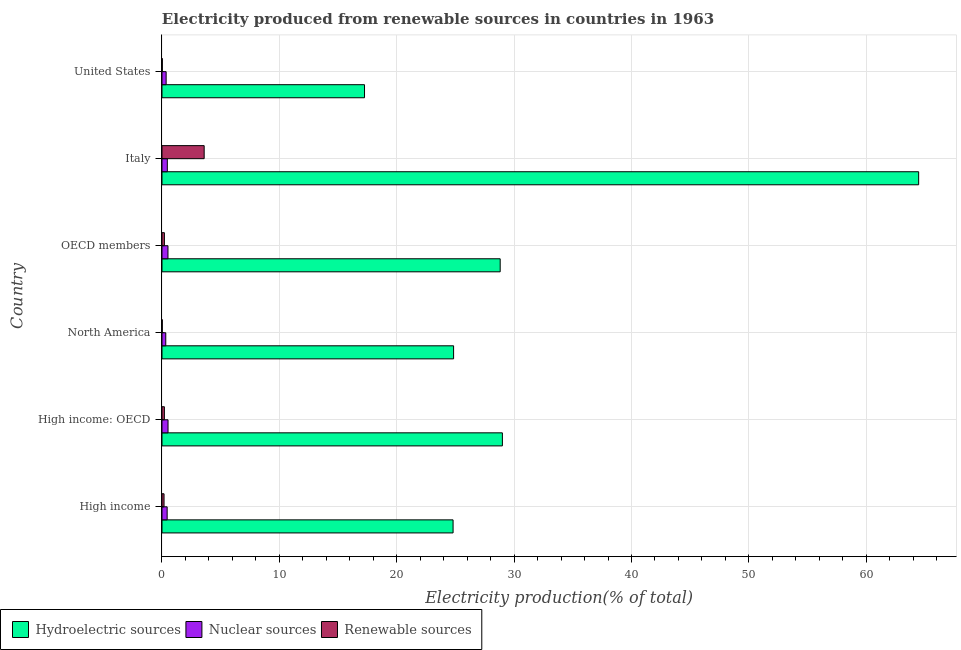How many different coloured bars are there?
Make the answer very short. 3. How many groups of bars are there?
Your answer should be compact. 6. Are the number of bars per tick equal to the number of legend labels?
Your answer should be compact. Yes. How many bars are there on the 1st tick from the bottom?
Your answer should be compact. 3. What is the percentage of electricity produced by nuclear sources in Italy?
Ensure brevity in your answer.  0.45. Across all countries, what is the maximum percentage of electricity produced by nuclear sources?
Keep it short and to the point. 0.52. Across all countries, what is the minimum percentage of electricity produced by renewable sources?
Offer a terse response. 0.03. In which country was the percentage of electricity produced by renewable sources maximum?
Offer a terse response. Italy. What is the total percentage of electricity produced by hydroelectric sources in the graph?
Keep it short and to the point. 189.19. What is the difference between the percentage of electricity produced by nuclear sources in High income and that in OECD members?
Your answer should be compact. -0.07. What is the difference between the percentage of electricity produced by hydroelectric sources in OECD members and the percentage of electricity produced by nuclear sources in North America?
Ensure brevity in your answer.  28.49. What is the average percentage of electricity produced by hydroelectric sources per country?
Provide a succinct answer. 31.53. What is the difference between the percentage of electricity produced by renewable sources and percentage of electricity produced by hydroelectric sources in High income: OECD?
Your answer should be very brief. -28.8. In how many countries, is the percentage of electricity produced by hydroelectric sources greater than 16 %?
Provide a short and direct response. 6. What is the ratio of the percentage of electricity produced by nuclear sources in High income to that in United States?
Offer a terse response. 1.25. Is the percentage of electricity produced by hydroelectric sources in High income: OECD less than that in Italy?
Provide a succinct answer. Yes. Is the difference between the percentage of electricity produced by hydroelectric sources in Italy and United States greater than the difference between the percentage of electricity produced by nuclear sources in Italy and United States?
Offer a terse response. Yes. What is the difference between the highest and the second highest percentage of electricity produced by hydroelectric sources?
Your answer should be very brief. 35.47. What is the difference between the highest and the lowest percentage of electricity produced by nuclear sources?
Your answer should be compact. 0.19. In how many countries, is the percentage of electricity produced by hydroelectric sources greater than the average percentage of electricity produced by hydroelectric sources taken over all countries?
Ensure brevity in your answer.  1. Is the sum of the percentage of electricity produced by renewable sources in High income: OECD and North America greater than the maximum percentage of electricity produced by hydroelectric sources across all countries?
Your answer should be compact. No. What does the 3rd bar from the top in United States represents?
Provide a short and direct response. Hydroelectric sources. What does the 1st bar from the bottom in OECD members represents?
Your answer should be very brief. Hydroelectric sources. Is it the case that in every country, the sum of the percentage of electricity produced by hydroelectric sources and percentage of electricity produced by nuclear sources is greater than the percentage of electricity produced by renewable sources?
Your answer should be very brief. Yes. What is the difference between two consecutive major ticks on the X-axis?
Keep it short and to the point. 10. Does the graph contain any zero values?
Provide a succinct answer. No. How many legend labels are there?
Provide a succinct answer. 3. How are the legend labels stacked?
Your response must be concise. Horizontal. What is the title of the graph?
Provide a short and direct response. Electricity produced from renewable sources in countries in 1963. What is the Electricity production(% of total) in Hydroelectric sources in High income?
Provide a succinct answer. 24.8. What is the Electricity production(% of total) of Nuclear sources in High income?
Give a very brief answer. 0.44. What is the Electricity production(% of total) in Renewable sources in High income?
Your response must be concise. 0.18. What is the Electricity production(% of total) in Hydroelectric sources in High income: OECD?
Keep it short and to the point. 29. What is the Electricity production(% of total) of Nuclear sources in High income: OECD?
Make the answer very short. 0.52. What is the Electricity production(% of total) in Renewable sources in High income: OECD?
Ensure brevity in your answer.  0.21. What is the Electricity production(% of total) of Hydroelectric sources in North America?
Ensure brevity in your answer.  24.84. What is the Electricity production(% of total) in Nuclear sources in North America?
Your answer should be very brief. 0.32. What is the Electricity production(% of total) of Renewable sources in North America?
Provide a short and direct response. 0.03. What is the Electricity production(% of total) in Hydroelectric sources in OECD members?
Offer a very short reply. 28.81. What is the Electricity production(% of total) in Nuclear sources in OECD members?
Give a very brief answer. 0.51. What is the Electricity production(% of total) of Renewable sources in OECD members?
Offer a terse response. 0.21. What is the Electricity production(% of total) in Hydroelectric sources in Italy?
Your response must be concise. 64.47. What is the Electricity production(% of total) in Nuclear sources in Italy?
Provide a short and direct response. 0.45. What is the Electricity production(% of total) of Renewable sources in Italy?
Your response must be concise. 3.59. What is the Electricity production(% of total) of Hydroelectric sources in United States?
Your response must be concise. 17.26. What is the Electricity production(% of total) of Nuclear sources in United States?
Provide a short and direct response. 0.35. What is the Electricity production(% of total) of Renewable sources in United States?
Keep it short and to the point. 0.03. Across all countries, what is the maximum Electricity production(% of total) in Hydroelectric sources?
Offer a very short reply. 64.47. Across all countries, what is the maximum Electricity production(% of total) in Nuclear sources?
Make the answer very short. 0.52. Across all countries, what is the maximum Electricity production(% of total) of Renewable sources?
Keep it short and to the point. 3.59. Across all countries, what is the minimum Electricity production(% of total) in Hydroelectric sources?
Make the answer very short. 17.26. Across all countries, what is the minimum Electricity production(% of total) in Nuclear sources?
Make the answer very short. 0.32. Across all countries, what is the minimum Electricity production(% of total) in Renewable sources?
Offer a very short reply. 0.03. What is the total Electricity production(% of total) in Hydroelectric sources in the graph?
Keep it short and to the point. 189.19. What is the total Electricity production(% of total) of Nuclear sources in the graph?
Ensure brevity in your answer.  2.6. What is the total Electricity production(% of total) in Renewable sources in the graph?
Ensure brevity in your answer.  4.24. What is the difference between the Electricity production(% of total) in Hydroelectric sources in High income and that in High income: OECD?
Give a very brief answer. -4.2. What is the difference between the Electricity production(% of total) of Nuclear sources in High income and that in High income: OECD?
Give a very brief answer. -0.07. What is the difference between the Electricity production(% of total) of Renewable sources in High income and that in High income: OECD?
Your answer should be compact. -0.03. What is the difference between the Electricity production(% of total) of Hydroelectric sources in High income and that in North America?
Your answer should be compact. -0.04. What is the difference between the Electricity production(% of total) in Nuclear sources in High income and that in North America?
Your answer should be compact. 0.12. What is the difference between the Electricity production(% of total) in Renewable sources in High income and that in North America?
Offer a very short reply. 0.15. What is the difference between the Electricity production(% of total) in Hydroelectric sources in High income and that in OECD members?
Make the answer very short. -4.01. What is the difference between the Electricity production(% of total) in Nuclear sources in High income and that in OECD members?
Your answer should be very brief. -0.07. What is the difference between the Electricity production(% of total) of Renewable sources in High income and that in OECD members?
Offer a terse response. -0.03. What is the difference between the Electricity production(% of total) of Hydroelectric sources in High income and that in Italy?
Your answer should be very brief. -39.67. What is the difference between the Electricity production(% of total) of Nuclear sources in High income and that in Italy?
Offer a very short reply. -0.01. What is the difference between the Electricity production(% of total) in Renewable sources in High income and that in Italy?
Your answer should be compact. -3.42. What is the difference between the Electricity production(% of total) of Hydroelectric sources in High income and that in United States?
Keep it short and to the point. 7.55. What is the difference between the Electricity production(% of total) in Nuclear sources in High income and that in United States?
Your answer should be compact. 0.09. What is the difference between the Electricity production(% of total) in Renewable sources in High income and that in United States?
Your answer should be compact. 0.15. What is the difference between the Electricity production(% of total) in Hydroelectric sources in High income: OECD and that in North America?
Offer a terse response. 4.16. What is the difference between the Electricity production(% of total) in Nuclear sources in High income: OECD and that in North America?
Your answer should be compact. 0.19. What is the difference between the Electricity production(% of total) in Renewable sources in High income: OECD and that in North America?
Your answer should be very brief. 0.18. What is the difference between the Electricity production(% of total) of Hydroelectric sources in High income: OECD and that in OECD members?
Make the answer very short. 0.19. What is the difference between the Electricity production(% of total) of Nuclear sources in High income: OECD and that in OECD members?
Make the answer very short. 0.01. What is the difference between the Electricity production(% of total) of Renewable sources in High income: OECD and that in OECD members?
Offer a very short reply. -0. What is the difference between the Electricity production(% of total) in Hydroelectric sources in High income: OECD and that in Italy?
Your answer should be very brief. -35.47. What is the difference between the Electricity production(% of total) of Nuclear sources in High income: OECD and that in Italy?
Give a very brief answer. 0.06. What is the difference between the Electricity production(% of total) in Renewable sources in High income: OECD and that in Italy?
Make the answer very short. -3.39. What is the difference between the Electricity production(% of total) of Hydroelectric sources in High income: OECD and that in United States?
Give a very brief answer. 11.75. What is the difference between the Electricity production(% of total) of Nuclear sources in High income: OECD and that in United States?
Provide a succinct answer. 0.16. What is the difference between the Electricity production(% of total) of Renewable sources in High income: OECD and that in United States?
Make the answer very short. 0.18. What is the difference between the Electricity production(% of total) in Hydroelectric sources in North America and that in OECD members?
Keep it short and to the point. -3.97. What is the difference between the Electricity production(% of total) of Nuclear sources in North America and that in OECD members?
Provide a short and direct response. -0.19. What is the difference between the Electricity production(% of total) of Renewable sources in North America and that in OECD members?
Provide a succinct answer. -0.18. What is the difference between the Electricity production(% of total) of Hydroelectric sources in North America and that in Italy?
Your response must be concise. -39.62. What is the difference between the Electricity production(% of total) in Nuclear sources in North America and that in Italy?
Offer a terse response. -0.13. What is the difference between the Electricity production(% of total) of Renewable sources in North America and that in Italy?
Your answer should be compact. -3.57. What is the difference between the Electricity production(% of total) in Hydroelectric sources in North America and that in United States?
Your answer should be compact. 7.59. What is the difference between the Electricity production(% of total) in Nuclear sources in North America and that in United States?
Your answer should be compact. -0.03. What is the difference between the Electricity production(% of total) of Renewable sources in North America and that in United States?
Give a very brief answer. -0. What is the difference between the Electricity production(% of total) of Hydroelectric sources in OECD members and that in Italy?
Make the answer very short. -35.65. What is the difference between the Electricity production(% of total) in Nuclear sources in OECD members and that in Italy?
Give a very brief answer. 0.06. What is the difference between the Electricity production(% of total) in Renewable sources in OECD members and that in Italy?
Your answer should be compact. -3.39. What is the difference between the Electricity production(% of total) in Hydroelectric sources in OECD members and that in United States?
Ensure brevity in your answer.  11.56. What is the difference between the Electricity production(% of total) of Nuclear sources in OECD members and that in United States?
Provide a succinct answer. 0.16. What is the difference between the Electricity production(% of total) of Renewable sources in OECD members and that in United States?
Provide a short and direct response. 0.18. What is the difference between the Electricity production(% of total) in Hydroelectric sources in Italy and that in United States?
Provide a short and direct response. 47.21. What is the difference between the Electricity production(% of total) in Nuclear sources in Italy and that in United States?
Make the answer very short. 0.1. What is the difference between the Electricity production(% of total) in Renewable sources in Italy and that in United States?
Provide a short and direct response. 3.56. What is the difference between the Electricity production(% of total) of Hydroelectric sources in High income and the Electricity production(% of total) of Nuclear sources in High income: OECD?
Make the answer very short. 24.29. What is the difference between the Electricity production(% of total) in Hydroelectric sources in High income and the Electricity production(% of total) in Renewable sources in High income: OECD?
Your answer should be compact. 24.6. What is the difference between the Electricity production(% of total) in Nuclear sources in High income and the Electricity production(% of total) in Renewable sources in High income: OECD?
Provide a short and direct response. 0.24. What is the difference between the Electricity production(% of total) in Hydroelectric sources in High income and the Electricity production(% of total) in Nuclear sources in North America?
Ensure brevity in your answer.  24.48. What is the difference between the Electricity production(% of total) in Hydroelectric sources in High income and the Electricity production(% of total) in Renewable sources in North America?
Give a very brief answer. 24.77. What is the difference between the Electricity production(% of total) of Nuclear sources in High income and the Electricity production(% of total) of Renewable sources in North America?
Offer a terse response. 0.41. What is the difference between the Electricity production(% of total) of Hydroelectric sources in High income and the Electricity production(% of total) of Nuclear sources in OECD members?
Offer a terse response. 24.29. What is the difference between the Electricity production(% of total) of Hydroelectric sources in High income and the Electricity production(% of total) of Renewable sources in OECD members?
Provide a short and direct response. 24.59. What is the difference between the Electricity production(% of total) in Nuclear sources in High income and the Electricity production(% of total) in Renewable sources in OECD members?
Offer a very short reply. 0.23. What is the difference between the Electricity production(% of total) in Hydroelectric sources in High income and the Electricity production(% of total) in Nuclear sources in Italy?
Give a very brief answer. 24.35. What is the difference between the Electricity production(% of total) in Hydroelectric sources in High income and the Electricity production(% of total) in Renewable sources in Italy?
Offer a very short reply. 21.21. What is the difference between the Electricity production(% of total) of Nuclear sources in High income and the Electricity production(% of total) of Renewable sources in Italy?
Your answer should be very brief. -3.15. What is the difference between the Electricity production(% of total) in Hydroelectric sources in High income and the Electricity production(% of total) in Nuclear sources in United States?
Your response must be concise. 24.45. What is the difference between the Electricity production(% of total) of Hydroelectric sources in High income and the Electricity production(% of total) of Renewable sources in United States?
Your response must be concise. 24.77. What is the difference between the Electricity production(% of total) of Nuclear sources in High income and the Electricity production(% of total) of Renewable sources in United States?
Ensure brevity in your answer.  0.41. What is the difference between the Electricity production(% of total) of Hydroelectric sources in High income: OECD and the Electricity production(% of total) of Nuclear sources in North America?
Provide a succinct answer. 28.68. What is the difference between the Electricity production(% of total) in Hydroelectric sources in High income: OECD and the Electricity production(% of total) in Renewable sources in North America?
Provide a short and direct response. 28.98. What is the difference between the Electricity production(% of total) of Nuclear sources in High income: OECD and the Electricity production(% of total) of Renewable sources in North America?
Keep it short and to the point. 0.49. What is the difference between the Electricity production(% of total) in Hydroelectric sources in High income: OECD and the Electricity production(% of total) in Nuclear sources in OECD members?
Your answer should be very brief. 28.49. What is the difference between the Electricity production(% of total) of Hydroelectric sources in High income: OECD and the Electricity production(% of total) of Renewable sources in OECD members?
Your answer should be compact. 28.8. What is the difference between the Electricity production(% of total) in Nuclear sources in High income: OECD and the Electricity production(% of total) in Renewable sources in OECD members?
Ensure brevity in your answer.  0.31. What is the difference between the Electricity production(% of total) in Hydroelectric sources in High income: OECD and the Electricity production(% of total) in Nuclear sources in Italy?
Your answer should be very brief. 28.55. What is the difference between the Electricity production(% of total) of Hydroelectric sources in High income: OECD and the Electricity production(% of total) of Renewable sources in Italy?
Your answer should be compact. 25.41. What is the difference between the Electricity production(% of total) of Nuclear sources in High income: OECD and the Electricity production(% of total) of Renewable sources in Italy?
Make the answer very short. -3.08. What is the difference between the Electricity production(% of total) of Hydroelectric sources in High income: OECD and the Electricity production(% of total) of Nuclear sources in United States?
Keep it short and to the point. 28.65. What is the difference between the Electricity production(% of total) of Hydroelectric sources in High income: OECD and the Electricity production(% of total) of Renewable sources in United States?
Your answer should be very brief. 28.97. What is the difference between the Electricity production(% of total) of Nuclear sources in High income: OECD and the Electricity production(% of total) of Renewable sources in United States?
Provide a short and direct response. 0.49. What is the difference between the Electricity production(% of total) of Hydroelectric sources in North America and the Electricity production(% of total) of Nuclear sources in OECD members?
Offer a terse response. 24.33. What is the difference between the Electricity production(% of total) in Hydroelectric sources in North America and the Electricity production(% of total) in Renewable sources in OECD members?
Your answer should be very brief. 24.64. What is the difference between the Electricity production(% of total) in Nuclear sources in North America and the Electricity production(% of total) in Renewable sources in OECD members?
Make the answer very short. 0.12. What is the difference between the Electricity production(% of total) of Hydroelectric sources in North America and the Electricity production(% of total) of Nuclear sources in Italy?
Keep it short and to the point. 24.39. What is the difference between the Electricity production(% of total) in Hydroelectric sources in North America and the Electricity production(% of total) in Renewable sources in Italy?
Offer a terse response. 21.25. What is the difference between the Electricity production(% of total) of Nuclear sources in North America and the Electricity production(% of total) of Renewable sources in Italy?
Offer a terse response. -3.27. What is the difference between the Electricity production(% of total) of Hydroelectric sources in North America and the Electricity production(% of total) of Nuclear sources in United States?
Offer a terse response. 24.49. What is the difference between the Electricity production(% of total) of Hydroelectric sources in North America and the Electricity production(% of total) of Renewable sources in United States?
Your response must be concise. 24.82. What is the difference between the Electricity production(% of total) in Nuclear sources in North America and the Electricity production(% of total) in Renewable sources in United States?
Ensure brevity in your answer.  0.29. What is the difference between the Electricity production(% of total) of Hydroelectric sources in OECD members and the Electricity production(% of total) of Nuclear sources in Italy?
Ensure brevity in your answer.  28.36. What is the difference between the Electricity production(% of total) of Hydroelectric sources in OECD members and the Electricity production(% of total) of Renewable sources in Italy?
Provide a short and direct response. 25.22. What is the difference between the Electricity production(% of total) of Nuclear sources in OECD members and the Electricity production(% of total) of Renewable sources in Italy?
Make the answer very short. -3.08. What is the difference between the Electricity production(% of total) in Hydroelectric sources in OECD members and the Electricity production(% of total) in Nuclear sources in United States?
Make the answer very short. 28.46. What is the difference between the Electricity production(% of total) in Hydroelectric sources in OECD members and the Electricity production(% of total) in Renewable sources in United States?
Your answer should be compact. 28.79. What is the difference between the Electricity production(% of total) of Nuclear sources in OECD members and the Electricity production(% of total) of Renewable sources in United States?
Your answer should be very brief. 0.48. What is the difference between the Electricity production(% of total) in Hydroelectric sources in Italy and the Electricity production(% of total) in Nuclear sources in United States?
Provide a succinct answer. 64.11. What is the difference between the Electricity production(% of total) in Hydroelectric sources in Italy and the Electricity production(% of total) in Renewable sources in United States?
Keep it short and to the point. 64.44. What is the difference between the Electricity production(% of total) of Nuclear sources in Italy and the Electricity production(% of total) of Renewable sources in United States?
Your response must be concise. 0.43. What is the average Electricity production(% of total) of Hydroelectric sources per country?
Keep it short and to the point. 31.53. What is the average Electricity production(% of total) in Nuclear sources per country?
Ensure brevity in your answer.  0.43. What is the average Electricity production(% of total) in Renewable sources per country?
Give a very brief answer. 0.71. What is the difference between the Electricity production(% of total) of Hydroelectric sources and Electricity production(% of total) of Nuclear sources in High income?
Your answer should be very brief. 24.36. What is the difference between the Electricity production(% of total) of Hydroelectric sources and Electricity production(% of total) of Renewable sources in High income?
Provide a short and direct response. 24.63. What is the difference between the Electricity production(% of total) of Nuclear sources and Electricity production(% of total) of Renewable sources in High income?
Your response must be concise. 0.27. What is the difference between the Electricity production(% of total) of Hydroelectric sources and Electricity production(% of total) of Nuclear sources in High income: OECD?
Provide a short and direct response. 28.49. What is the difference between the Electricity production(% of total) in Hydroelectric sources and Electricity production(% of total) in Renewable sources in High income: OECD?
Your answer should be very brief. 28.8. What is the difference between the Electricity production(% of total) in Nuclear sources and Electricity production(% of total) in Renewable sources in High income: OECD?
Offer a terse response. 0.31. What is the difference between the Electricity production(% of total) in Hydroelectric sources and Electricity production(% of total) in Nuclear sources in North America?
Your response must be concise. 24.52. What is the difference between the Electricity production(% of total) of Hydroelectric sources and Electricity production(% of total) of Renewable sources in North America?
Your answer should be very brief. 24.82. What is the difference between the Electricity production(% of total) of Nuclear sources and Electricity production(% of total) of Renewable sources in North America?
Make the answer very short. 0.3. What is the difference between the Electricity production(% of total) of Hydroelectric sources and Electricity production(% of total) of Nuclear sources in OECD members?
Make the answer very short. 28.3. What is the difference between the Electricity production(% of total) in Hydroelectric sources and Electricity production(% of total) in Renewable sources in OECD members?
Make the answer very short. 28.61. What is the difference between the Electricity production(% of total) of Nuclear sources and Electricity production(% of total) of Renewable sources in OECD members?
Provide a succinct answer. 0.3. What is the difference between the Electricity production(% of total) in Hydroelectric sources and Electricity production(% of total) in Nuclear sources in Italy?
Ensure brevity in your answer.  64.01. What is the difference between the Electricity production(% of total) in Hydroelectric sources and Electricity production(% of total) in Renewable sources in Italy?
Make the answer very short. 60.87. What is the difference between the Electricity production(% of total) of Nuclear sources and Electricity production(% of total) of Renewable sources in Italy?
Give a very brief answer. -3.14. What is the difference between the Electricity production(% of total) of Hydroelectric sources and Electricity production(% of total) of Nuclear sources in United States?
Keep it short and to the point. 16.9. What is the difference between the Electricity production(% of total) in Hydroelectric sources and Electricity production(% of total) in Renewable sources in United States?
Make the answer very short. 17.23. What is the difference between the Electricity production(% of total) of Nuclear sources and Electricity production(% of total) of Renewable sources in United States?
Your answer should be very brief. 0.32. What is the ratio of the Electricity production(% of total) of Hydroelectric sources in High income to that in High income: OECD?
Offer a terse response. 0.86. What is the ratio of the Electricity production(% of total) of Nuclear sources in High income to that in High income: OECD?
Give a very brief answer. 0.86. What is the ratio of the Electricity production(% of total) in Renewable sources in High income to that in High income: OECD?
Your answer should be very brief. 0.86. What is the ratio of the Electricity production(% of total) of Hydroelectric sources in High income to that in North America?
Your response must be concise. 1. What is the ratio of the Electricity production(% of total) of Nuclear sources in High income to that in North America?
Keep it short and to the point. 1.37. What is the ratio of the Electricity production(% of total) in Renewable sources in High income to that in North America?
Provide a succinct answer. 6.73. What is the ratio of the Electricity production(% of total) of Hydroelectric sources in High income to that in OECD members?
Your answer should be compact. 0.86. What is the ratio of the Electricity production(% of total) of Nuclear sources in High income to that in OECD members?
Your response must be concise. 0.86. What is the ratio of the Electricity production(% of total) of Renewable sources in High income to that in OECD members?
Your answer should be very brief. 0.85. What is the ratio of the Electricity production(% of total) in Hydroelectric sources in High income to that in Italy?
Your response must be concise. 0.38. What is the ratio of the Electricity production(% of total) of Nuclear sources in High income to that in Italy?
Offer a very short reply. 0.97. What is the ratio of the Electricity production(% of total) in Renewable sources in High income to that in Italy?
Your answer should be very brief. 0.05. What is the ratio of the Electricity production(% of total) of Hydroelectric sources in High income to that in United States?
Ensure brevity in your answer.  1.44. What is the ratio of the Electricity production(% of total) of Nuclear sources in High income to that in United States?
Provide a succinct answer. 1.25. What is the ratio of the Electricity production(% of total) in Renewable sources in High income to that in United States?
Offer a terse response. 5.97. What is the ratio of the Electricity production(% of total) of Hydroelectric sources in High income: OECD to that in North America?
Provide a short and direct response. 1.17. What is the ratio of the Electricity production(% of total) of Nuclear sources in High income: OECD to that in North America?
Your answer should be very brief. 1.6. What is the ratio of the Electricity production(% of total) in Renewable sources in High income: OECD to that in North America?
Keep it short and to the point. 7.87. What is the ratio of the Electricity production(% of total) in Hydroelectric sources in High income: OECD to that in OECD members?
Offer a terse response. 1.01. What is the ratio of the Electricity production(% of total) of Renewable sources in High income: OECD to that in OECD members?
Provide a succinct answer. 1. What is the ratio of the Electricity production(% of total) of Hydroelectric sources in High income: OECD to that in Italy?
Ensure brevity in your answer.  0.45. What is the ratio of the Electricity production(% of total) in Nuclear sources in High income: OECD to that in Italy?
Keep it short and to the point. 1.13. What is the ratio of the Electricity production(% of total) of Renewable sources in High income: OECD to that in Italy?
Make the answer very short. 0.06. What is the ratio of the Electricity production(% of total) of Hydroelectric sources in High income: OECD to that in United States?
Your answer should be compact. 1.68. What is the ratio of the Electricity production(% of total) in Nuclear sources in High income: OECD to that in United States?
Provide a succinct answer. 1.46. What is the ratio of the Electricity production(% of total) in Renewable sources in High income: OECD to that in United States?
Your response must be concise. 6.98. What is the ratio of the Electricity production(% of total) of Hydroelectric sources in North America to that in OECD members?
Keep it short and to the point. 0.86. What is the ratio of the Electricity production(% of total) in Nuclear sources in North America to that in OECD members?
Provide a short and direct response. 0.63. What is the ratio of the Electricity production(% of total) in Renewable sources in North America to that in OECD members?
Your answer should be compact. 0.13. What is the ratio of the Electricity production(% of total) in Hydroelectric sources in North America to that in Italy?
Offer a very short reply. 0.39. What is the ratio of the Electricity production(% of total) of Nuclear sources in North America to that in Italy?
Offer a very short reply. 0.71. What is the ratio of the Electricity production(% of total) of Renewable sources in North America to that in Italy?
Ensure brevity in your answer.  0.01. What is the ratio of the Electricity production(% of total) in Hydroelectric sources in North America to that in United States?
Your answer should be very brief. 1.44. What is the ratio of the Electricity production(% of total) in Nuclear sources in North America to that in United States?
Offer a very short reply. 0.91. What is the ratio of the Electricity production(% of total) in Renewable sources in North America to that in United States?
Provide a succinct answer. 0.89. What is the ratio of the Electricity production(% of total) in Hydroelectric sources in OECD members to that in Italy?
Provide a short and direct response. 0.45. What is the ratio of the Electricity production(% of total) in Nuclear sources in OECD members to that in Italy?
Keep it short and to the point. 1.12. What is the ratio of the Electricity production(% of total) in Renewable sources in OECD members to that in Italy?
Your answer should be very brief. 0.06. What is the ratio of the Electricity production(% of total) in Hydroelectric sources in OECD members to that in United States?
Provide a succinct answer. 1.67. What is the ratio of the Electricity production(% of total) of Nuclear sources in OECD members to that in United States?
Offer a very short reply. 1.44. What is the ratio of the Electricity production(% of total) of Renewable sources in OECD members to that in United States?
Keep it short and to the point. 7.01. What is the ratio of the Electricity production(% of total) of Hydroelectric sources in Italy to that in United States?
Your answer should be very brief. 3.74. What is the ratio of the Electricity production(% of total) in Nuclear sources in Italy to that in United States?
Provide a succinct answer. 1.29. What is the ratio of the Electricity production(% of total) of Renewable sources in Italy to that in United States?
Offer a very short reply. 122.12. What is the difference between the highest and the second highest Electricity production(% of total) in Hydroelectric sources?
Provide a short and direct response. 35.47. What is the difference between the highest and the second highest Electricity production(% of total) of Nuclear sources?
Provide a short and direct response. 0.01. What is the difference between the highest and the second highest Electricity production(% of total) of Renewable sources?
Your response must be concise. 3.39. What is the difference between the highest and the lowest Electricity production(% of total) of Hydroelectric sources?
Your response must be concise. 47.21. What is the difference between the highest and the lowest Electricity production(% of total) in Nuclear sources?
Provide a short and direct response. 0.19. What is the difference between the highest and the lowest Electricity production(% of total) in Renewable sources?
Your response must be concise. 3.57. 